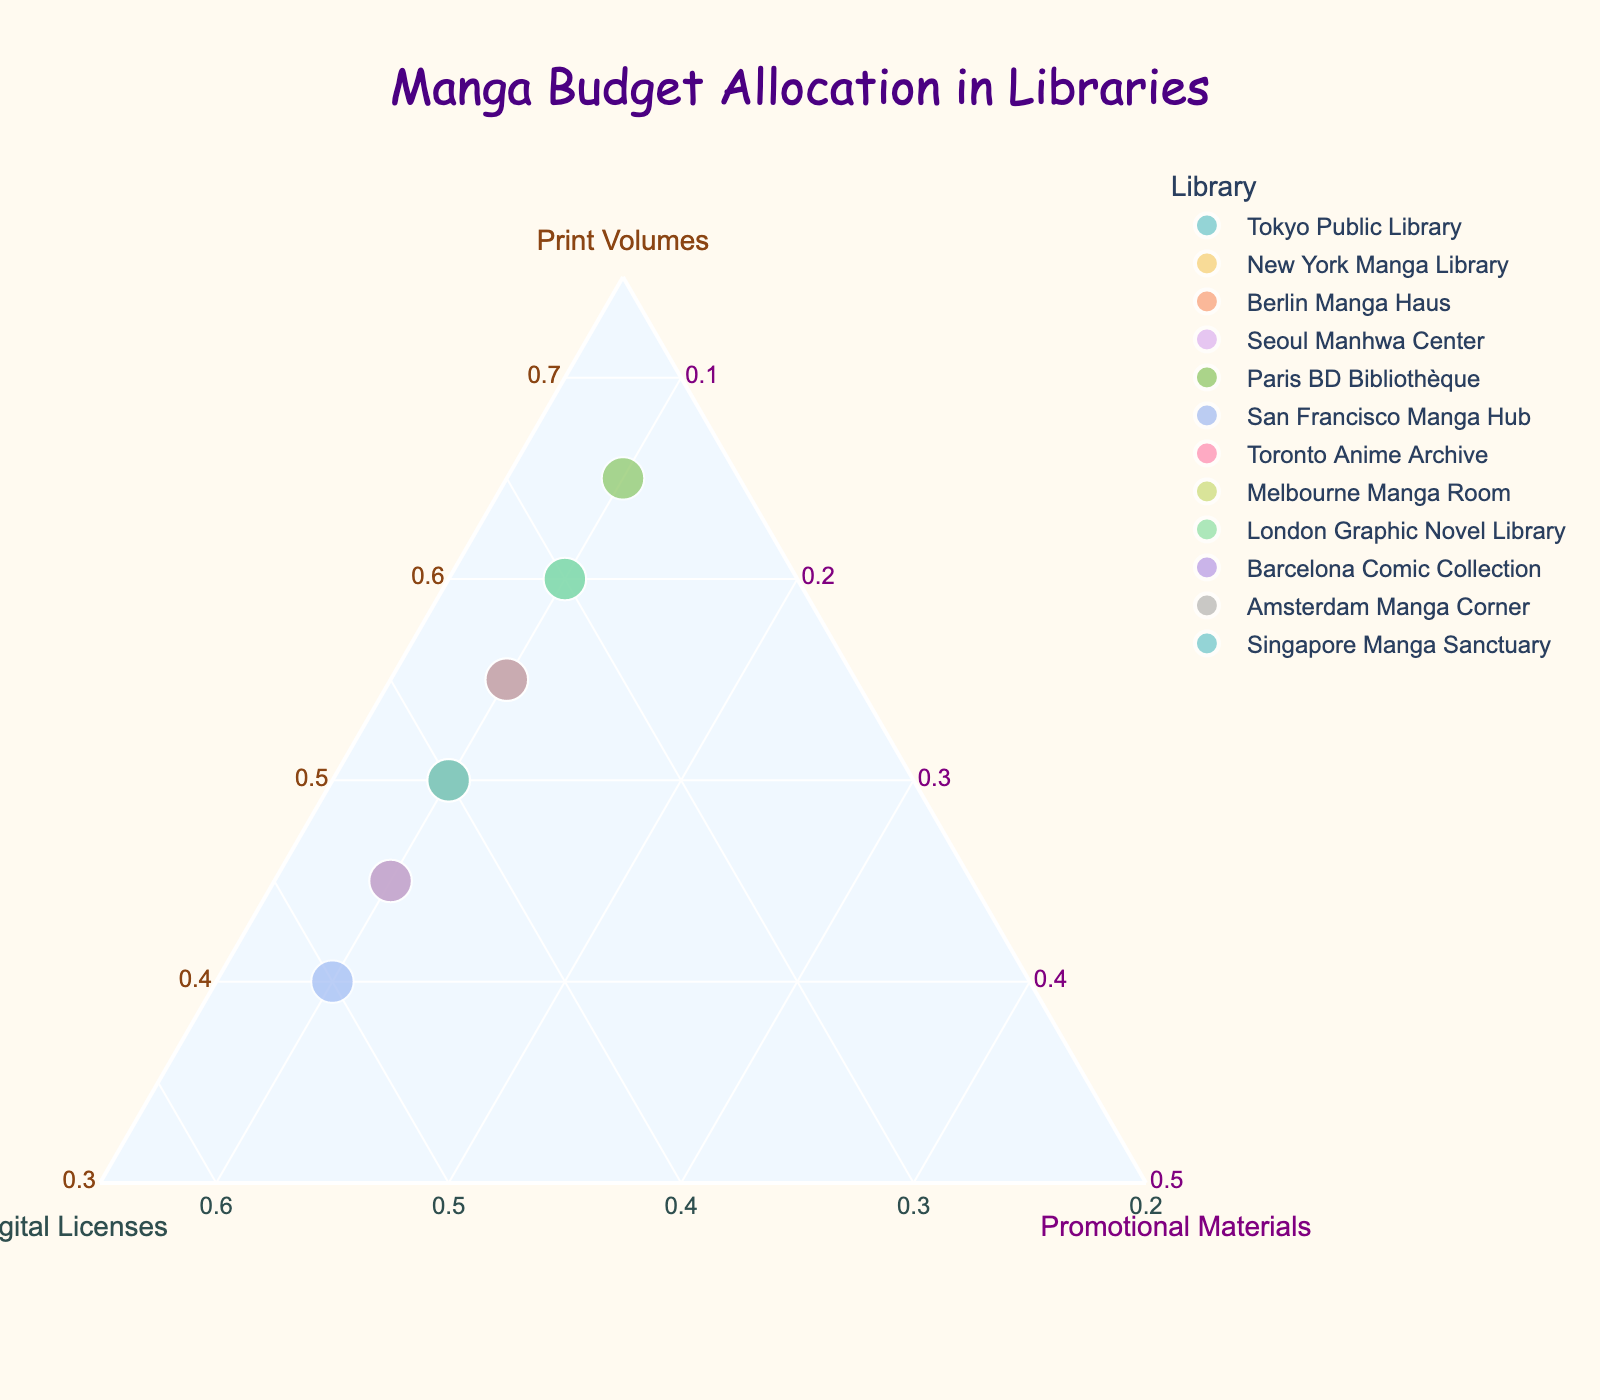How many libraries are on the plot? Count the number of data points on the plot, each representing a different library.
Answer: 12 What is the range of budget allocation for Print Volumes? Look at the axis labeled "Print Volumes" and identify the minimum and maximum values of the data points on that axis.
Answer: 40% to 65% Which library has the highest budget allocated to Digital Licenses? Find the data point located highest along the "Digital Licenses" axis to identify the library.
Answer: San Francisco Manga Hub How many libraries allocate exactly 10% of their budget to Promotional Materials? Count the number of data points situated at 10% along the "Promotional Materials" axis.
Answer: 12 Which library has an equal allocation for Print Volumes and Digital Licenses? Find the data points that are equidistant from the "Print Volumes" and "Digital Licenses" axes.
Answer: New York Manga Library and Barcelona Comic Collection What is the average proportion allocated to Print Volumes across all libraries? Sum the proportions for Print Volumes from all libraries and divide by the number of libraries. For example, (60 + 45 + 55 + 50 + 65 + 40 + 55 + 50 + 60 + 45 + 55 + 50) / 12 = 55%.
Answer: 55% Which library has the least budget allocated to Digital Licenses? Identify the data point positioned lowest along the "Digital Licenses" axis to find the library.
Answer: Paris BD Bibliothèque What is the difference in allocation to Print Volumes between the Tokyo Public Library and the London Graphic Novel Library? Subtract the Print Volume percentage of London Graphic Novel Library from Tokyo Public Library. For example, 60% - 60% = 0%.
Answer: 0% How does Seoul Manhwa Center's allocation compare to Toronto Anime Archive's across all categories? Compare the proportions of the budget allocation for Print Volumes, Digital Licenses, and Promotional Materials for both libraries.
Answer: Print Volumes: 50% vs 55%, Digital Licenses: 40% vs 35%, Promotional Materials: 10% vs 10% Which library is closest to allocating equal proportions across all three categories? Identify the data point nearest to the center of the ternary plot, representing nearly equal allocation around 33% each.
Answer: New York Manga Library 